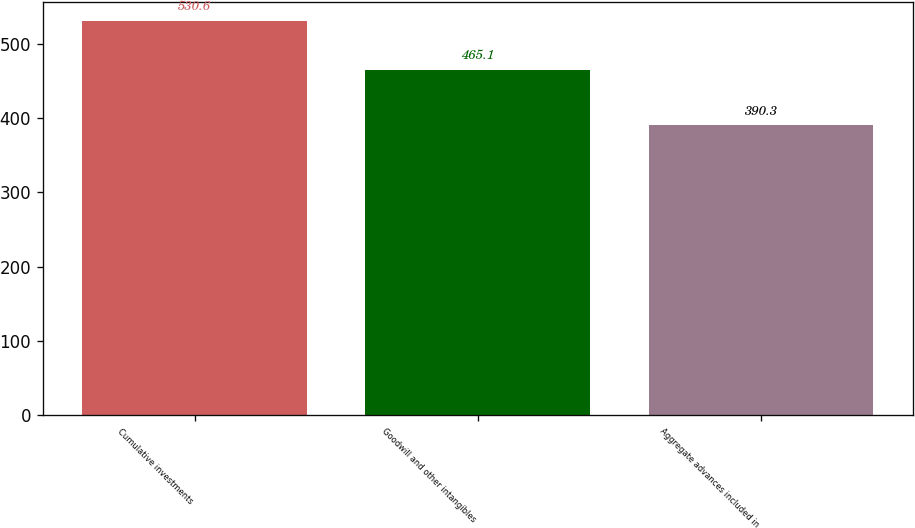Convert chart to OTSL. <chart><loc_0><loc_0><loc_500><loc_500><bar_chart><fcel>Cumulative investments<fcel>Goodwill and other intangibles<fcel>Aggregate advances included in<nl><fcel>530.6<fcel>465.1<fcel>390.3<nl></chart> 